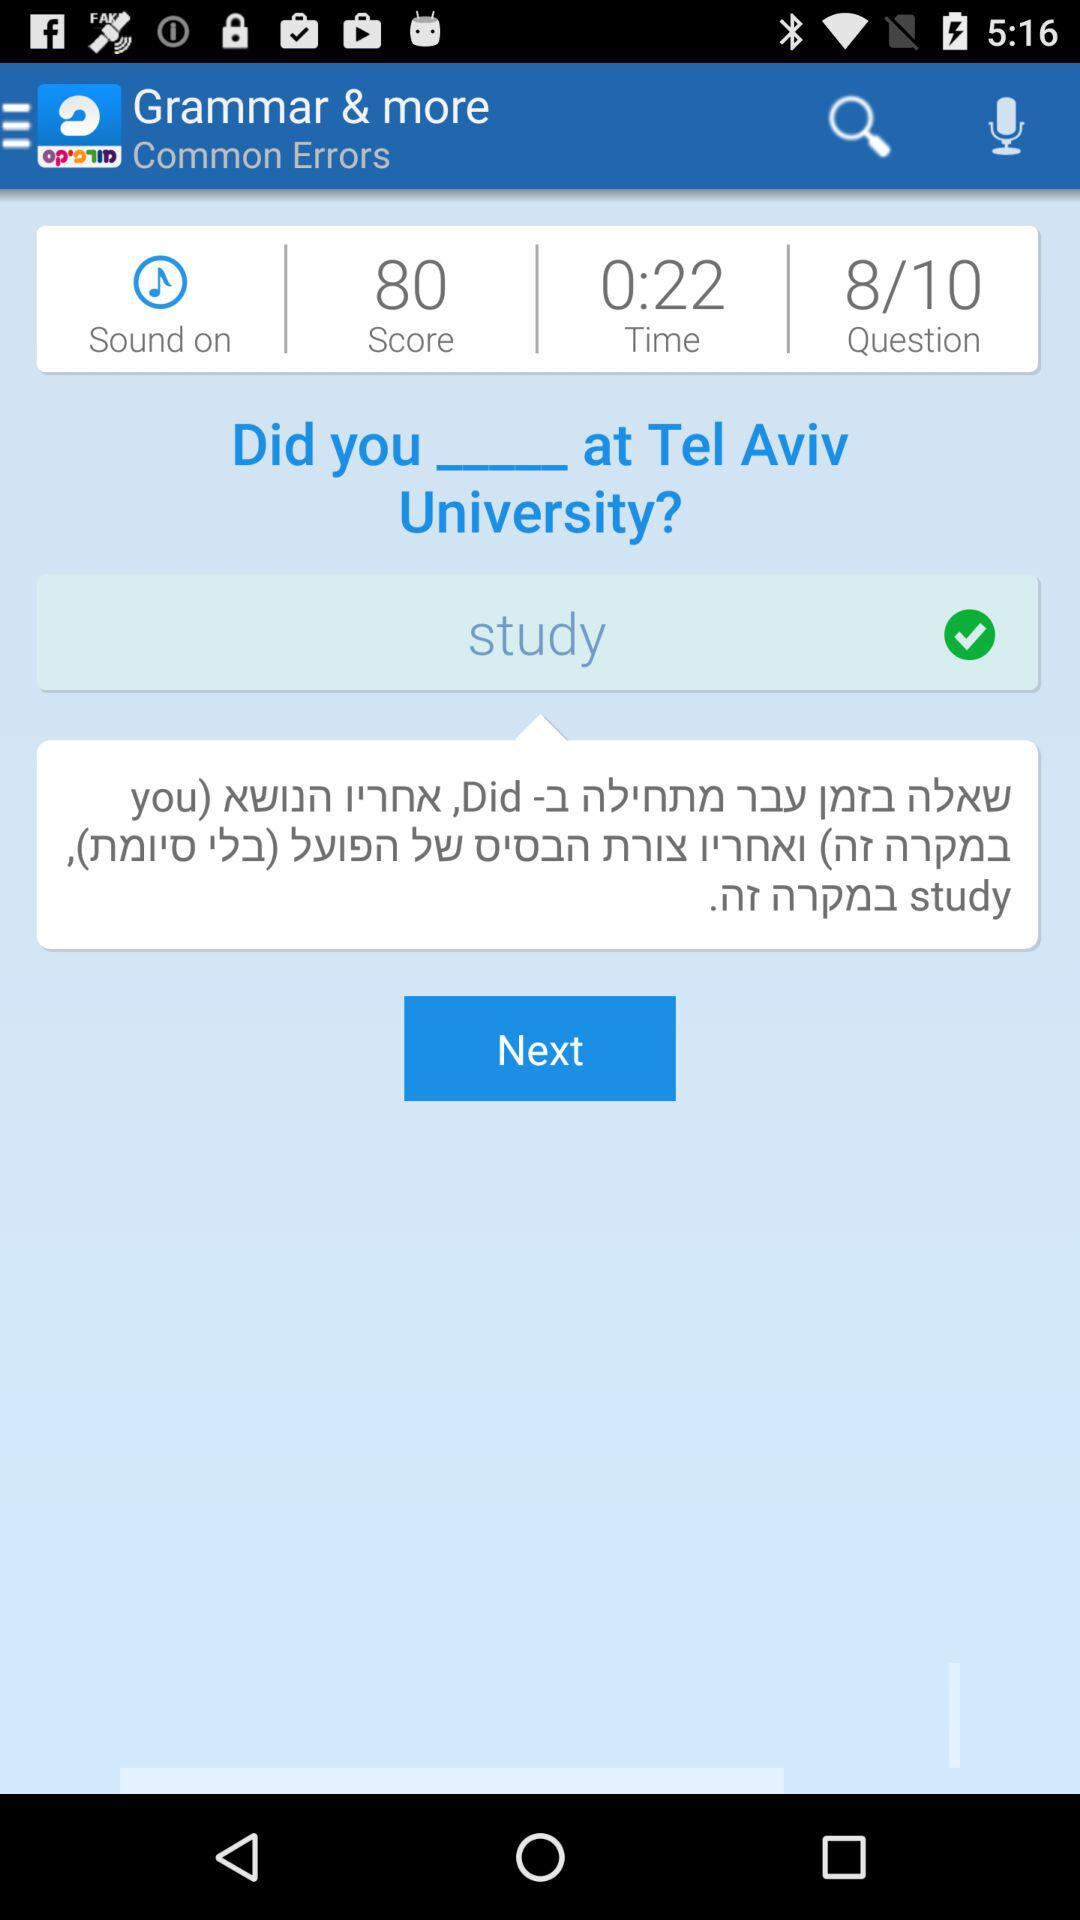What is the question? The question is, "Did you ________ at Tel Aviv University?". 